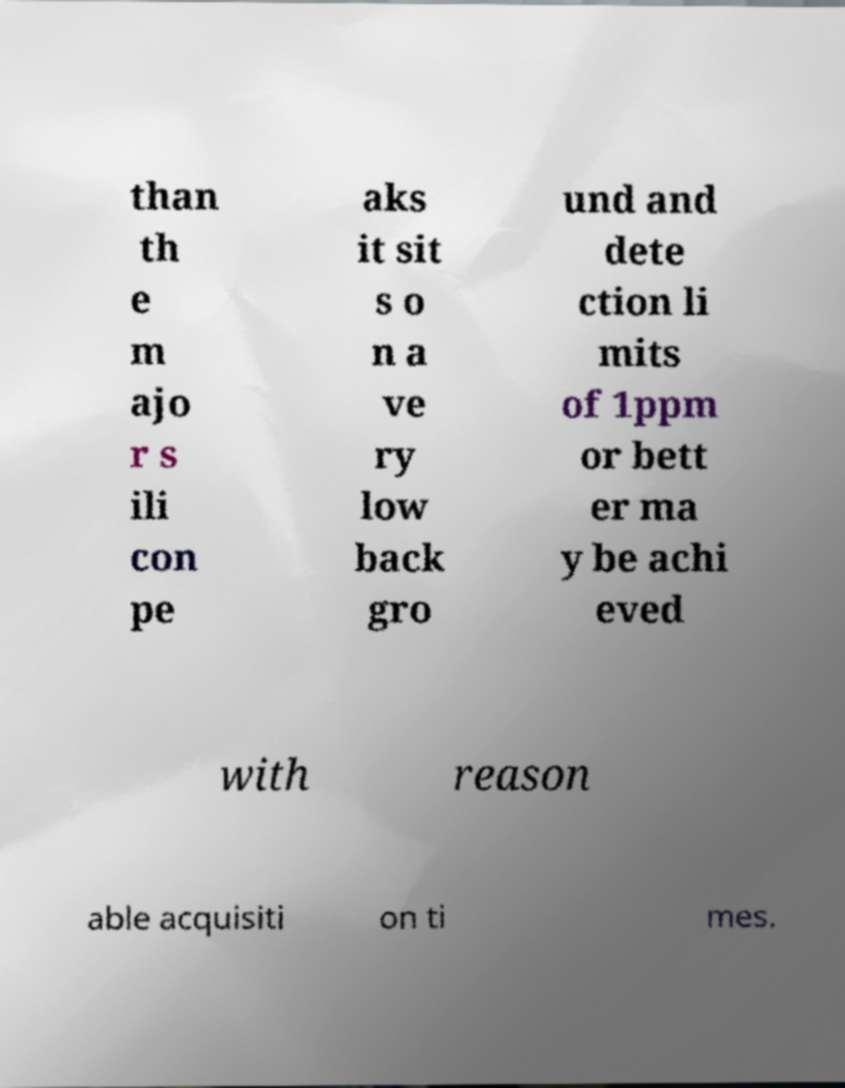For documentation purposes, I need the text within this image transcribed. Could you provide that? than th e m ajo r s ili con pe aks it sit s o n a ve ry low back gro und and dete ction li mits of 1ppm or bett er ma y be achi eved with reason able acquisiti on ti mes. 